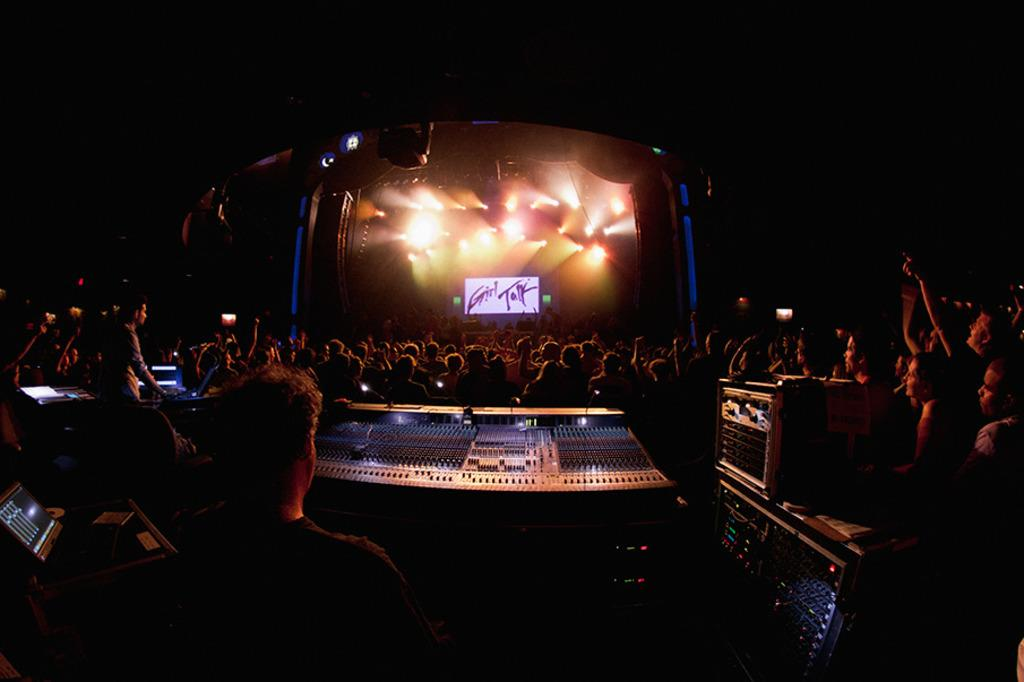What type of equipment is present in the image? There is DJ equipment in the image. What electronic device can be seen in the image? There is a laptop in the image. Can you describe the people in the image? There is a group of people in the image. What architectural feature is visible in the image? There is a roof in the image. What type of lighting is present in the image? There are lights in the image. What type of display device is present in the image? There is a screen in the image. Are there any other objects visible in the image? Yes, there are other objects in the image. What is the color of the background in the image? The background of the image is dark. What time does the clock in the image show? There is no clock present in the image. What type of nerve is visible in the image? There are no nerves visible in the image. 